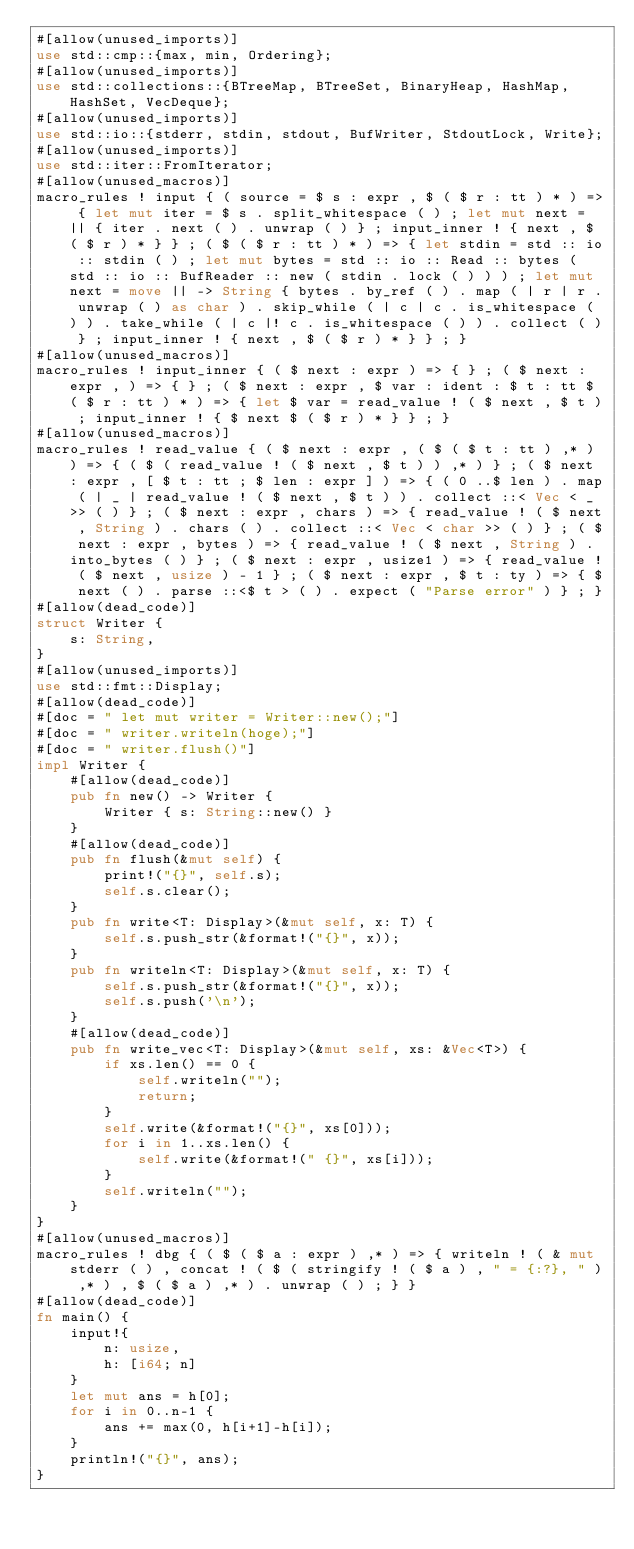<code> <loc_0><loc_0><loc_500><loc_500><_Rust_>#[allow(unused_imports)]
use std::cmp::{max, min, Ordering};
#[allow(unused_imports)]
use std::collections::{BTreeMap, BTreeSet, BinaryHeap, HashMap, HashSet, VecDeque};
#[allow(unused_imports)]
use std::io::{stderr, stdin, stdout, BufWriter, StdoutLock, Write};
#[allow(unused_imports)]
use std::iter::FromIterator;
#[allow(unused_macros)]
macro_rules ! input { ( source = $ s : expr , $ ( $ r : tt ) * ) => { let mut iter = $ s . split_whitespace ( ) ; let mut next = || { iter . next ( ) . unwrap ( ) } ; input_inner ! { next , $ ( $ r ) * } } ; ( $ ( $ r : tt ) * ) => { let stdin = std :: io :: stdin ( ) ; let mut bytes = std :: io :: Read :: bytes ( std :: io :: BufReader :: new ( stdin . lock ( ) ) ) ; let mut next = move || -> String { bytes . by_ref ( ) . map ( | r | r . unwrap ( ) as char ) . skip_while ( | c | c . is_whitespace ( ) ) . take_while ( | c |! c . is_whitespace ( ) ) . collect ( ) } ; input_inner ! { next , $ ( $ r ) * } } ; }
#[allow(unused_macros)]
macro_rules ! input_inner { ( $ next : expr ) => { } ; ( $ next : expr , ) => { } ; ( $ next : expr , $ var : ident : $ t : tt $ ( $ r : tt ) * ) => { let $ var = read_value ! ( $ next , $ t ) ; input_inner ! { $ next $ ( $ r ) * } } ; }
#[allow(unused_macros)]
macro_rules ! read_value { ( $ next : expr , ( $ ( $ t : tt ) ,* ) ) => { ( $ ( read_value ! ( $ next , $ t ) ) ,* ) } ; ( $ next : expr , [ $ t : tt ; $ len : expr ] ) => { ( 0 ..$ len ) . map ( | _ | read_value ! ( $ next , $ t ) ) . collect ::< Vec < _ >> ( ) } ; ( $ next : expr , chars ) => { read_value ! ( $ next , String ) . chars ( ) . collect ::< Vec < char >> ( ) } ; ( $ next : expr , bytes ) => { read_value ! ( $ next , String ) . into_bytes ( ) } ; ( $ next : expr , usize1 ) => { read_value ! ( $ next , usize ) - 1 } ; ( $ next : expr , $ t : ty ) => { $ next ( ) . parse ::<$ t > ( ) . expect ( "Parse error" ) } ; }
#[allow(dead_code)]
struct Writer {
    s: String,
}
#[allow(unused_imports)]
use std::fmt::Display;
#[allow(dead_code)]
#[doc = " let mut writer = Writer::new();"]
#[doc = " writer.writeln(hoge);"]
#[doc = " writer.flush()"]
impl Writer {
    #[allow(dead_code)]
    pub fn new() -> Writer {
        Writer { s: String::new() }
    }
    #[allow(dead_code)]
    pub fn flush(&mut self) {
        print!("{}", self.s);
        self.s.clear();
    }
    pub fn write<T: Display>(&mut self, x: T) {
        self.s.push_str(&format!("{}", x));
    }
    pub fn writeln<T: Display>(&mut self, x: T) {
        self.s.push_str(&format!("{}", x));
        self.s.push('\n');
    }
    #[allow(dead_code)]
    pub fn write_vec<T: Display>(&mut self, xs: &Vec<T>) {
        if xs.len() == 0 {
            self.writeln("");
            return;
        }
        self.write(&format!("{}", xs[0]));
        for i in 1..xs.len() {
            self.write(&format!(" {}", xs[i]));
        }
        self.writeln("");
    }
}
#[allow(unused_macros)]
macro_rules ! dbg { ( $ ( $ a : expr ) ,* ) => { writeln ! ( & mut stderr ( ) , concat ! ( $ ( stringify ! ( $ a ) , " = {:?}, " ) ,* ) , $ ( $ a ) ,* ) . unwrap ( ) ; } }
#[allow(dead_code)]
fn main() {
    input!{
        n: usize,
        h: [i64; n]
    }
    let mut ans = h[0];
    for i in 0..n-1 {
        ans += max(0, h[i+1]-h[i]);
    }
    println!("{}", ans);
}</code> 